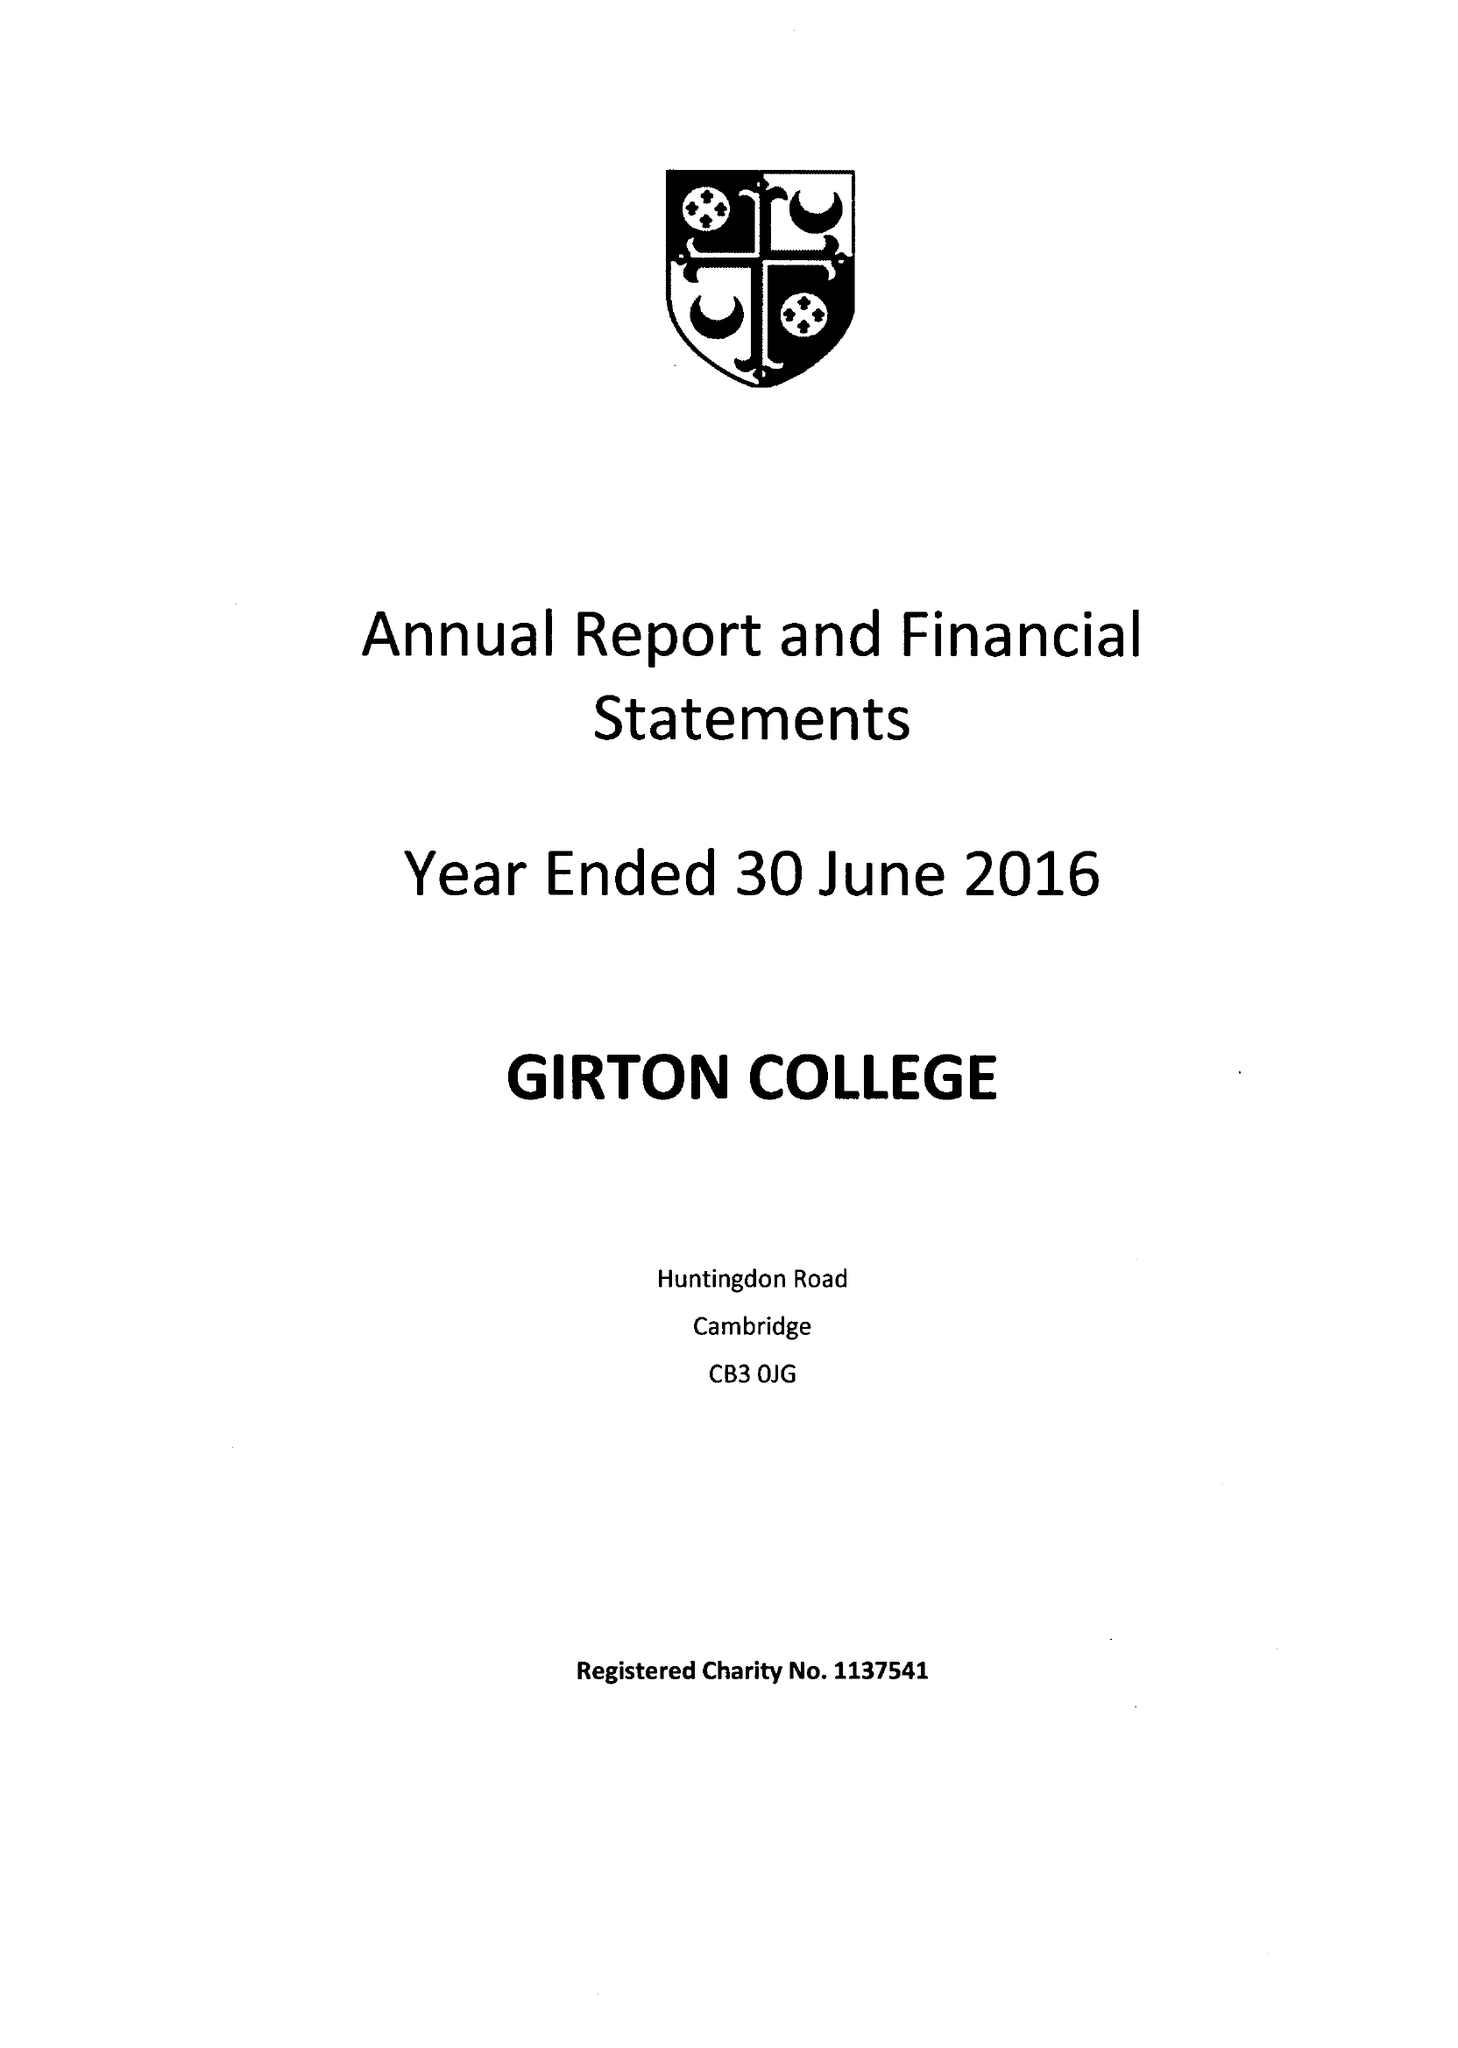What is the value for the report_date?
Answer the question using a single word or phrase. 2016-06-30 